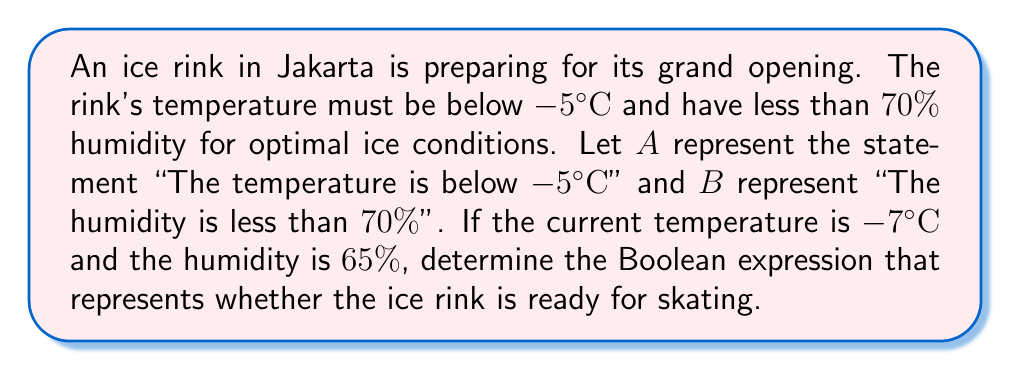Can you answer this question? Let's approach this step-by-step:

1) First, we need to evaluate the truth values of statements $A$ and $B$:

   $A$: "The temperature is below $-5°C$"
   The current temperature is $-7°C$, which is indeed below $-5°C$.
   Therefore, $A$ is true.

   $B$: "The humidity is less than $70\%$"
   The current humidity is $65\%$, which is less than $70\%$.
   Therefore, $B$ is also true.

2) For the ice rink to be ready, both conditions must be met simultaneously. In Boolean logic, this is represented by the AND operation, denoted by $\wedge$.

3) The Boolean expression for the ice rink being ready is:

   $A \wedge B$

4) Since both $A$ and $B$ are true, we can evaluate:

   $true \wedge true = true$

Therefore, the Boolean expression $A \wedge B$ evaluates to true, indicating that the ice rink is ready for skating.
Answer: $A \wedge B$ 